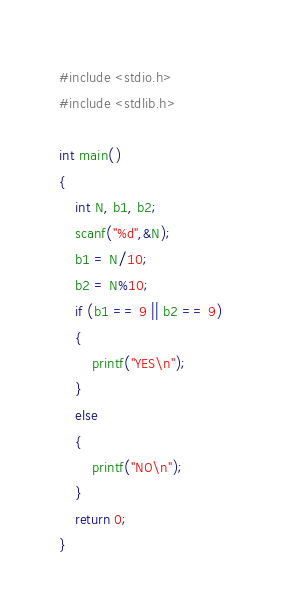Convert code to text. <code><loc_0><loc_0><loc_500><loc_500><_C_>#include <stdio.h>
#include <stdlib.h>

int main()
{
    int N, b1, b2;
    scanf("%d",&N);
    b1 = N/10;
    b2 = N%10;
    if (b1 == 9 || b2 == 9)
    {
        printf("YES\n");
    }
    else
    {
        printf("NO\n");
    }
    return 0;
}
</code> 